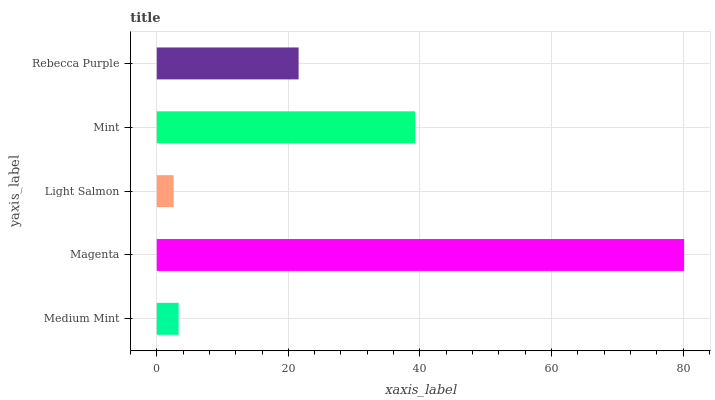Is Light Salmon the minimum?
Answer yes or no. Yes. Is Magenta the maximum?
Answer yes or no. Yes. Is Magenta the minimum?
Answer yes or no. No. Is Light Salmon the maximum?
Answer yes or no. No. Is Magenta greater than Light Salmon?
Answer yes or no. Yes. Is Light Salmon less than Magenta?
Answer yes or no. Yes. Is Light Salmon greater than Magenta?
Answer yes or no. No. Is Magenta less than Light Salmon?
Answer yes or no. No. Is Rebecca Purple the high median?
Answer yes or no. Yes. Is Rebecca Purple the low median?
Answer yes or no. Yes. Is Magenta the high median?
Answer yes or no. No. Is Medium Mint the low median?
Answer yes or no. No. 